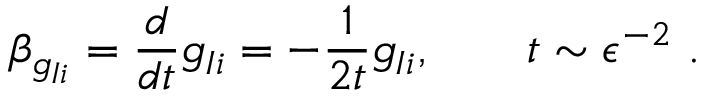Convert formula to latex. <formula><loc_0><loc_0><loc_500><loc_500>\beta _ { g _ { I i } } = \frac { d } { d t } g _ { I i } = - \frac { 1 } { 2 t } g _ { I i } , \quad t \sim \epsilon ^ { - 2 } .</formula> 